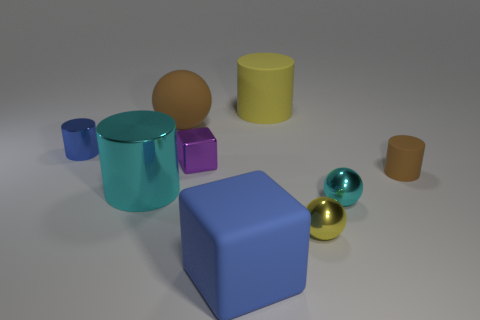Subtract all big brown matte balls. How many balls are left? 2 Subtract 1 blocks. How many blocks are left? 1 Add 8 green matte cylinders. How many green matte cylinders exist? 8 Subtract all purple cubes. How many cubes are left? 1 Subtract 0 brown cubes. How many objects are left? 9 Subtract all cylinders. How many objects are left? 5 Subtract all purple blocks. Subtract all cyan balls. How many blocks are left? 1 Subtract all brown cylinders. How many yellow balls are left? 1 Subtract all tiny brown metallic objects. Subtract all metal spheres. How many objects are left? 7 Add 2 tiny metallic balls. How many tiny metallic balls are left? 4 